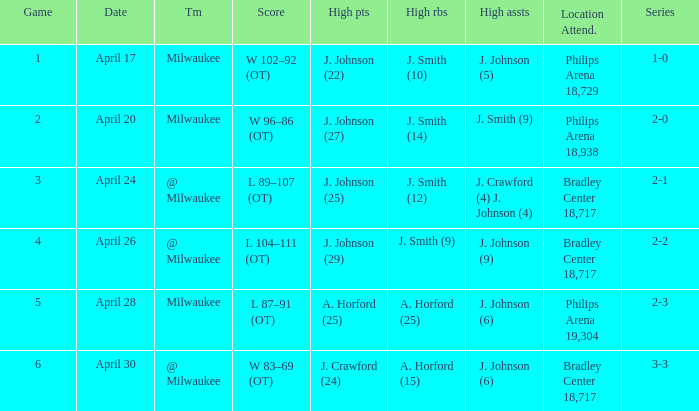What were the amount of rebounds in game 2? J. Smith (14). 